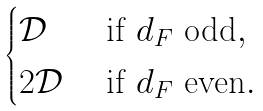<formula> <loc_0><loc_0><loc_500><loc_500>\begin{cases} \mathcal { D } & \text { if } d _ { F } \text { odd} , \\ 2 \mathcal { D } & \text { if } d _ { F } \text { even} . \end{cases}</formula> 